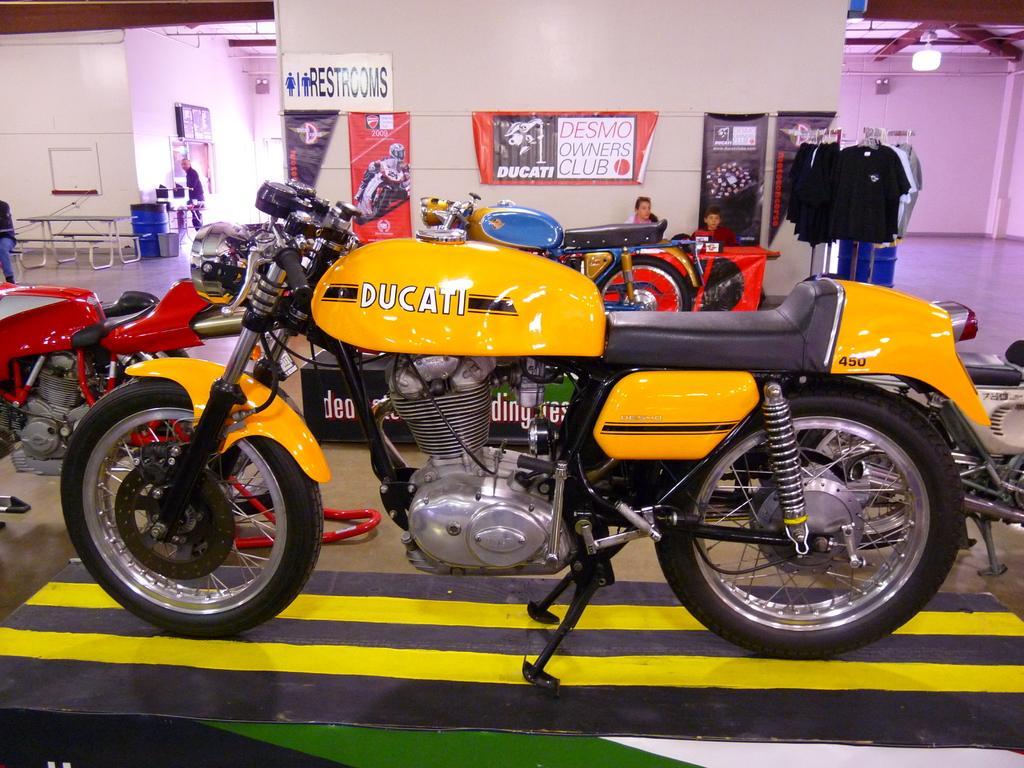Please provide a concise description of this image. In the picture I can see a bike which is in yellow color and there are few other bikes beside it and there are few posters attached to the wall and there are few clothes,two persons and some other objects in the background. 